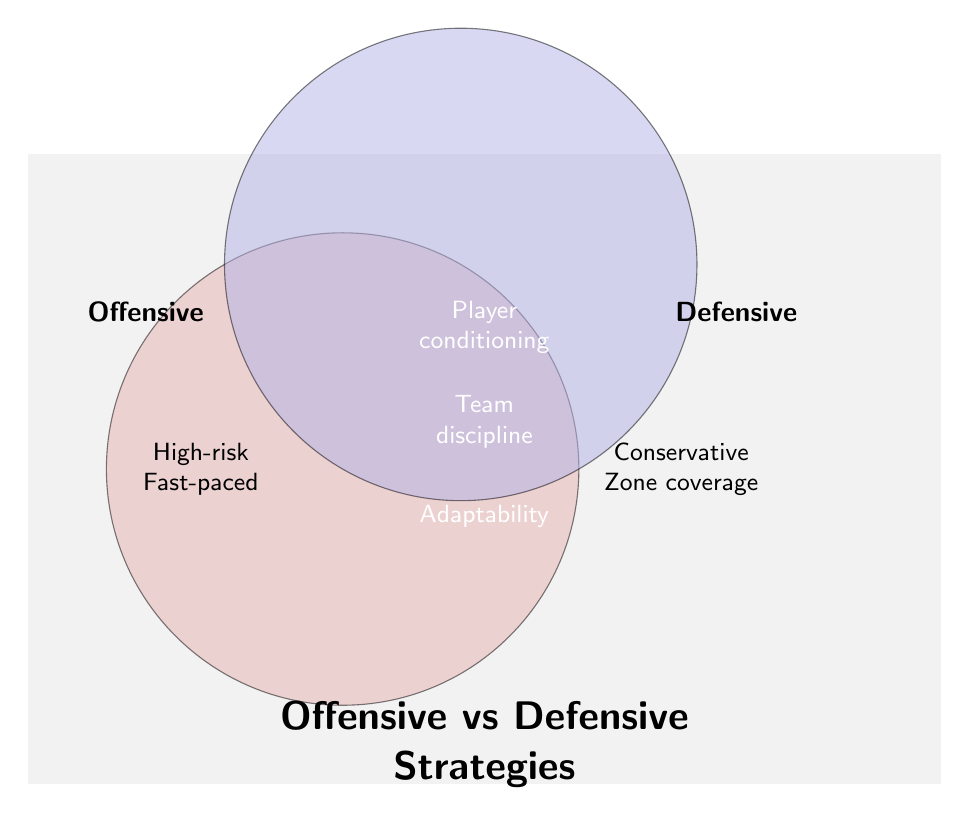What are the unique strategies to Offensive only? Look at the left circle of the Venn Diagram, which represents Offensive strategies. Identify the elements within this circle that do not overlap with the Defensive circle.
Answer: High-risk plays, Frequent passing, Aggressive scoring, Fast-paced drives, Wide receiver focus What strategies are shared between Offensive and Defensive? Check the overlapping area of the two circles in the Venn Diagram. This area shows the strategies that are common to both Offensive and Defensive strategies.
Answer: Player conditioning, Team discipline, Game analysis, Practice intensity, Adaptability Which strategy is exclusive to Defensive and involves coverage? Observe the elements in the Defensive circle that do not overlap with the Offensive circle and look for the one related to 'coverage.'
Answer: Zone coverage Compare the nature of Offensive and Defensive strategies. Refer to each circle, describe what kind of approaches are listed under Offensive and how they contrast with the approaches listed under Defensive.
Answer: Offensive: High-risk, aggressive, fast-paced; Defensive: Conservative, focused on prevention and control How many strategies are unique to the Defensive approach? Count the elements within the Defensive circle that are not in the overlapping area.
Answer: Four How does 'Team discipline' fit into both strategies? Locate 'Team discipline' in the Venn Diagram and explain its position in the overlap area between both circles, indicating its importance to both strategies.
Answer: Team discipline is crucial for both Offensive and Defensive approaches, ensuring structured and cohesive gameplay Can 'Frequent passing' and 'Blitz strategies' be used together? Check if 'Frequent passing' and 'Blitz strategies' fall within the same circle or if they are disparate elements within the Venn Diagram.
Answer: No Which side emphasizes a 'Turnover focus'? Find the 'Turnover focus' within the circles to determine if it's listed under Offensive, Defensive, or both.
Answer: Defensive only Identify strategies related to player preparation. Look at the overlapping area where strategies that involve both Offensive and Defensive elements are listed, focusing on those related to player readiness.
Answer: Player conditioning, Practice intensity Is 'Aggressive scoring' related to Defensive strategy? Check the position of 'Aggressive scoring' in the Venn Diagram to determine its classification as Offensive, Defensive, or shared.
Answer: No 